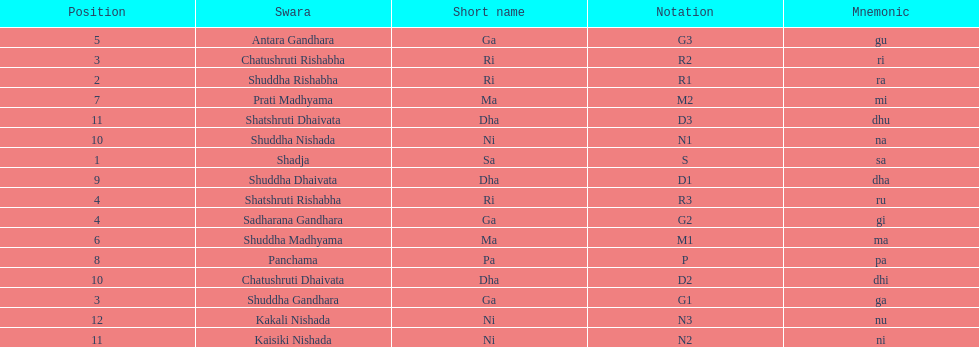Which swara holds the last position? Kakali Nishada. 